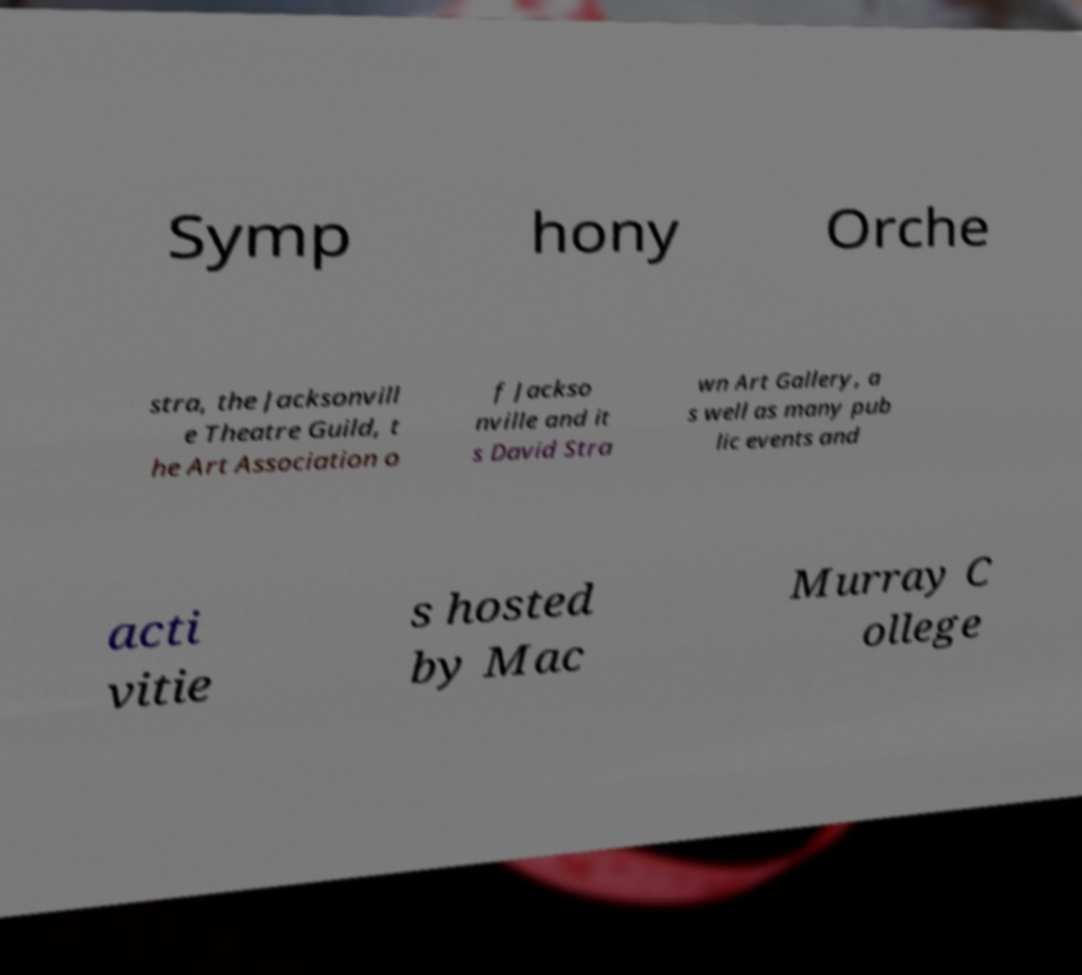Can you accurately transcribe the text from the provided image for me? Symp hony Orche stra, the Jacksonvill e Theatre Guild, t he Art Association o f Jackso nville and it s David Stra wn Art Gallery, a s well as many pub lic events and acti vitie s hosted by Mac Murray C ollege 